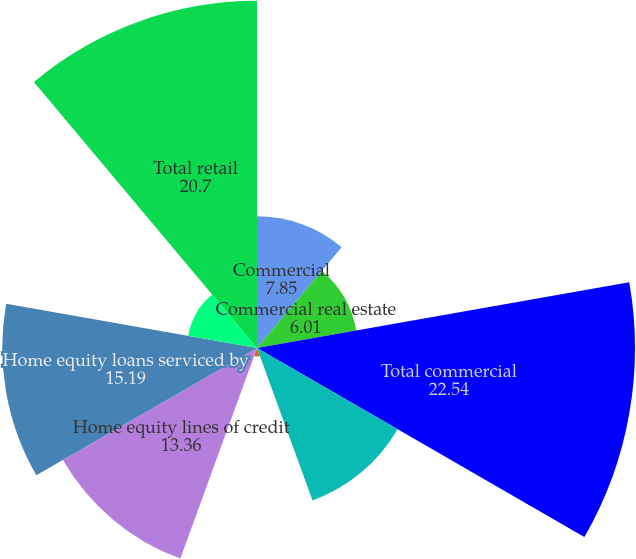Convert chart. <chart><loc_0><loc_0><loc_500><loc_500><pie_chart><fcel>Commercial<fcel>Commercial real estate<fcel>Total commercial<fcel>Residential mortgages<fcel>Home equity loans<fcel>Home equity lines of credit<fcel>Home equity loans serviced by<fcel>Student<fcel>Total retail<nl><fcel>7.85%<fcel>6.01%<fcel>22.54%<fcel>9.68%<fcel>0.5%<fcel>13.36%<fcel>15.19%<fcel>4.17%<fcel>20.7%<nl></chart> 